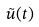<formula> <loc_0><loc_0><loc_500><loc_500>\tilde { u } ( t )</formula> 